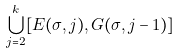<formula> <loc_0><loc_0><loc_500><loc_500>\bigcup _ { j = 2 } ^ { k } [ E ( \sigma , j ) , G ( \sigma , j - 1 ) ]</formula> 